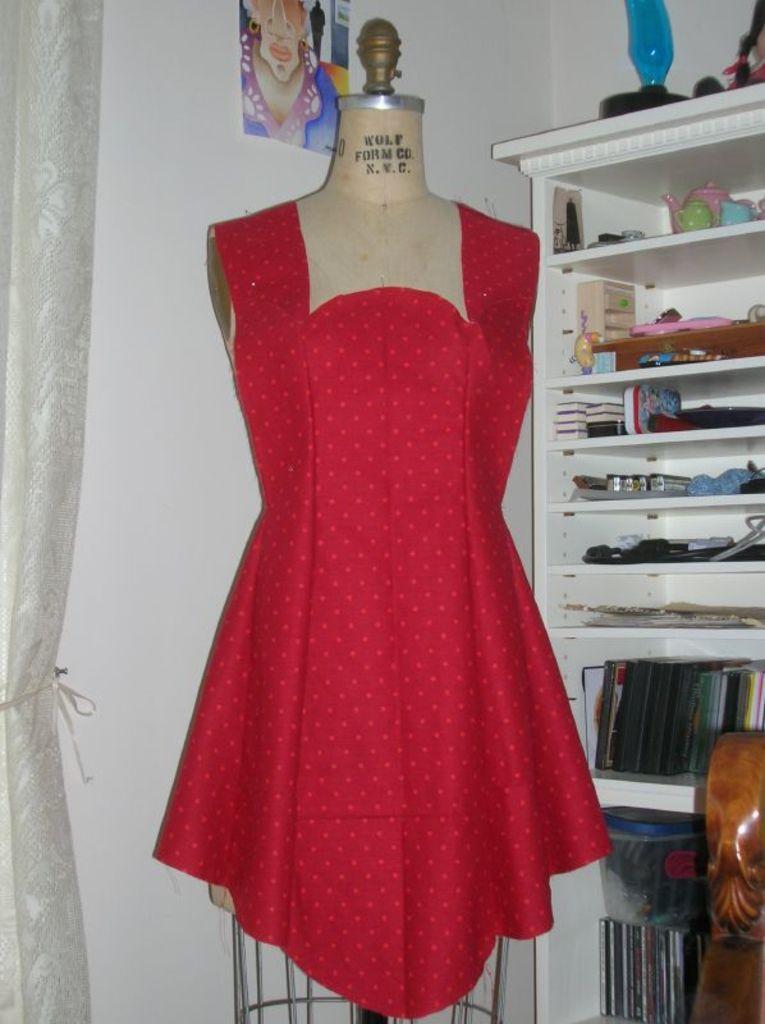How would you summarize this image in a sentence or two? This picture is clicked inside the room. On the left corner there is a white color curtain. In the center there is a mannequin wearing red color dress. In the background there is a poster on the wall and a white color cabinet containing books, cups, kettle and many other objects. 